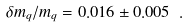Convert formula to latex. <formula><loc_0><loc_0><loc_500><loc_500>\delta m _ { q } / m _ { q } = 0 . 0 1 6 \pm 0 . 0 0 5 \ .</formula> 